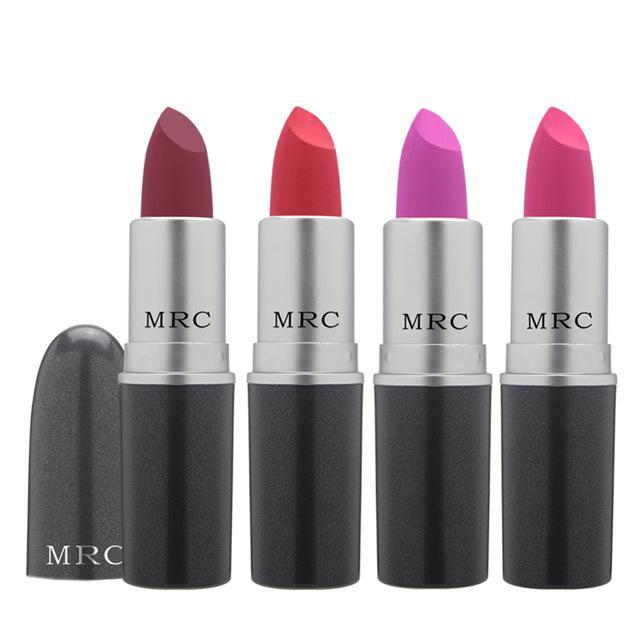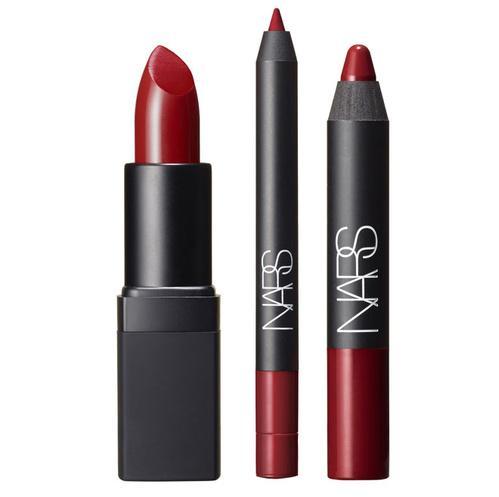The first image is the image on the left, the second image is the image on the right. Considering the images on both sides, is "There is one closed tube of lipstick in line with all of the open tubes of lipstick." valid? Answer yes or no. No. The first image is the image on the left, the second image is the image on the right. Evaluate the accuracy of this statement regarding the images: "There are exactly three lip makeups in the image on the right.". Is it true? Answer yes or no. Yes. 